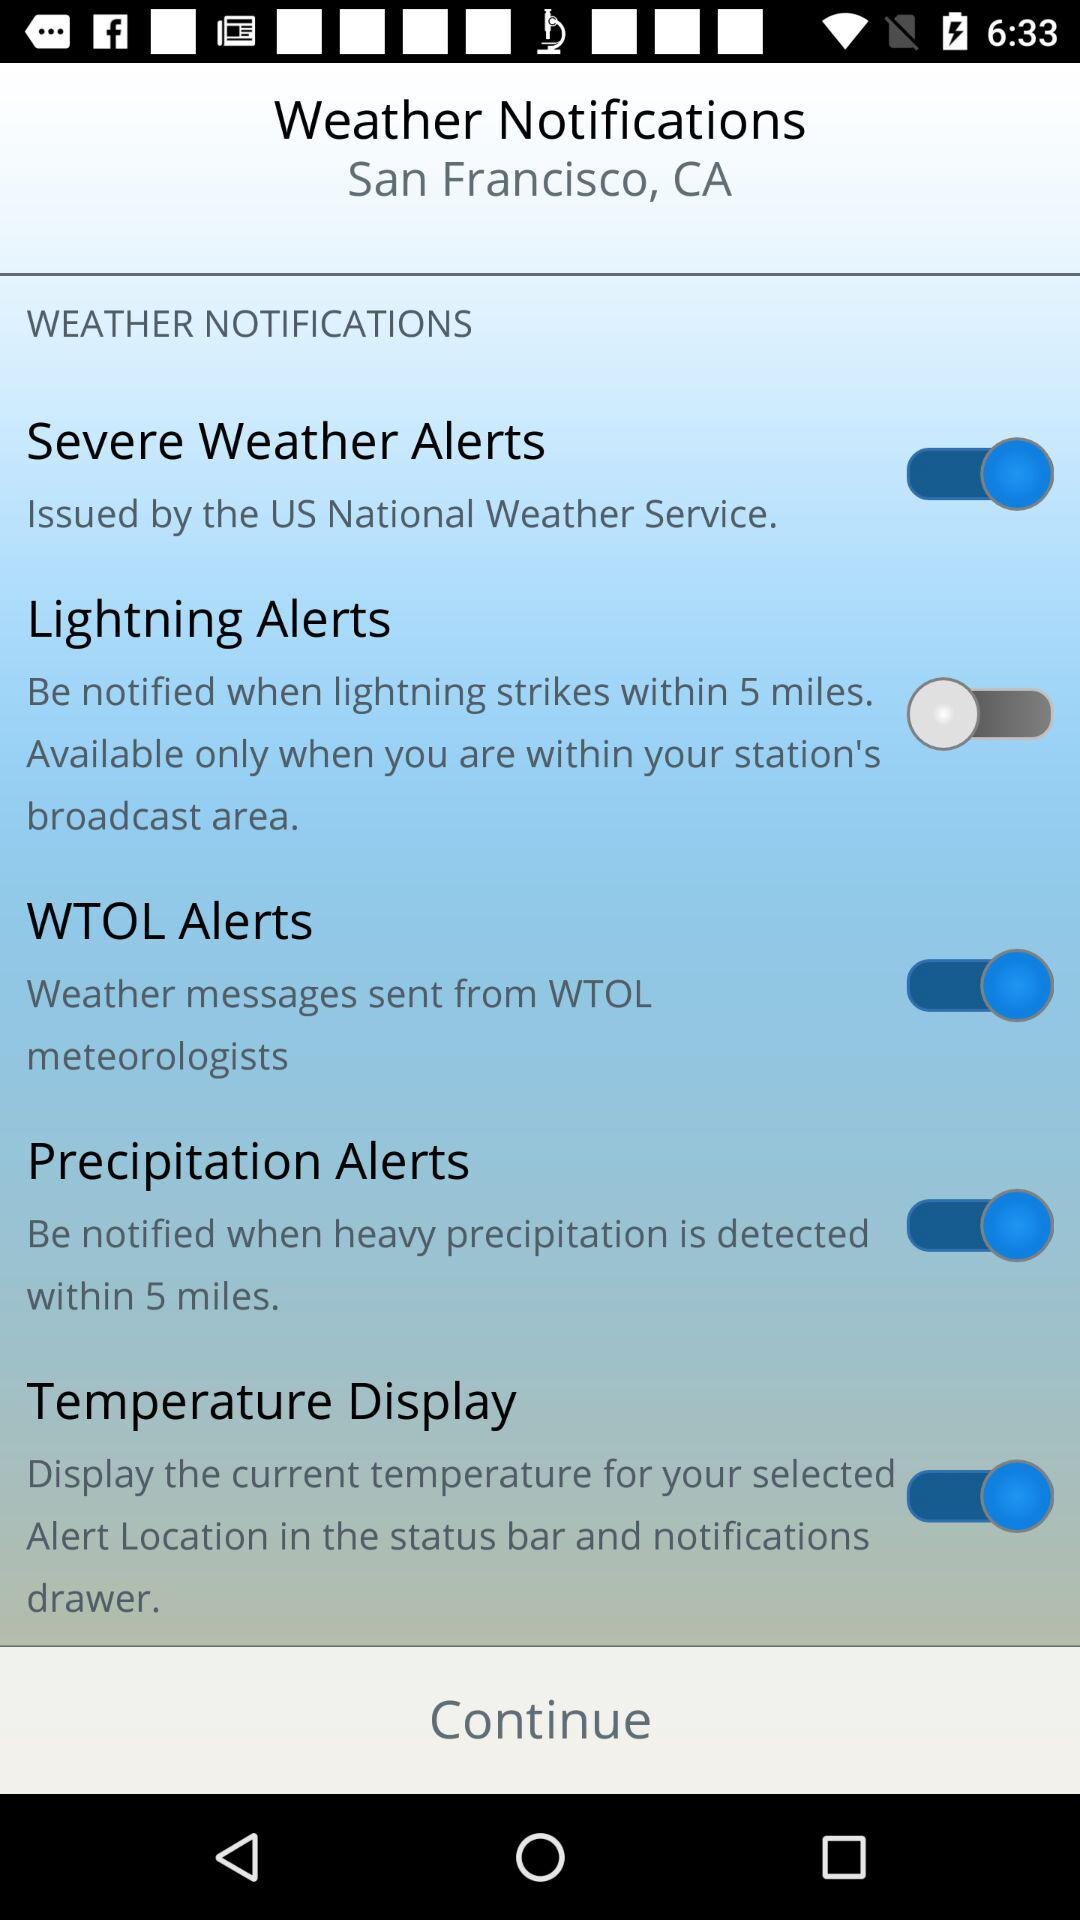How many of the weather notifications are enabled?
Answer the question using a single word or phrase. 4 